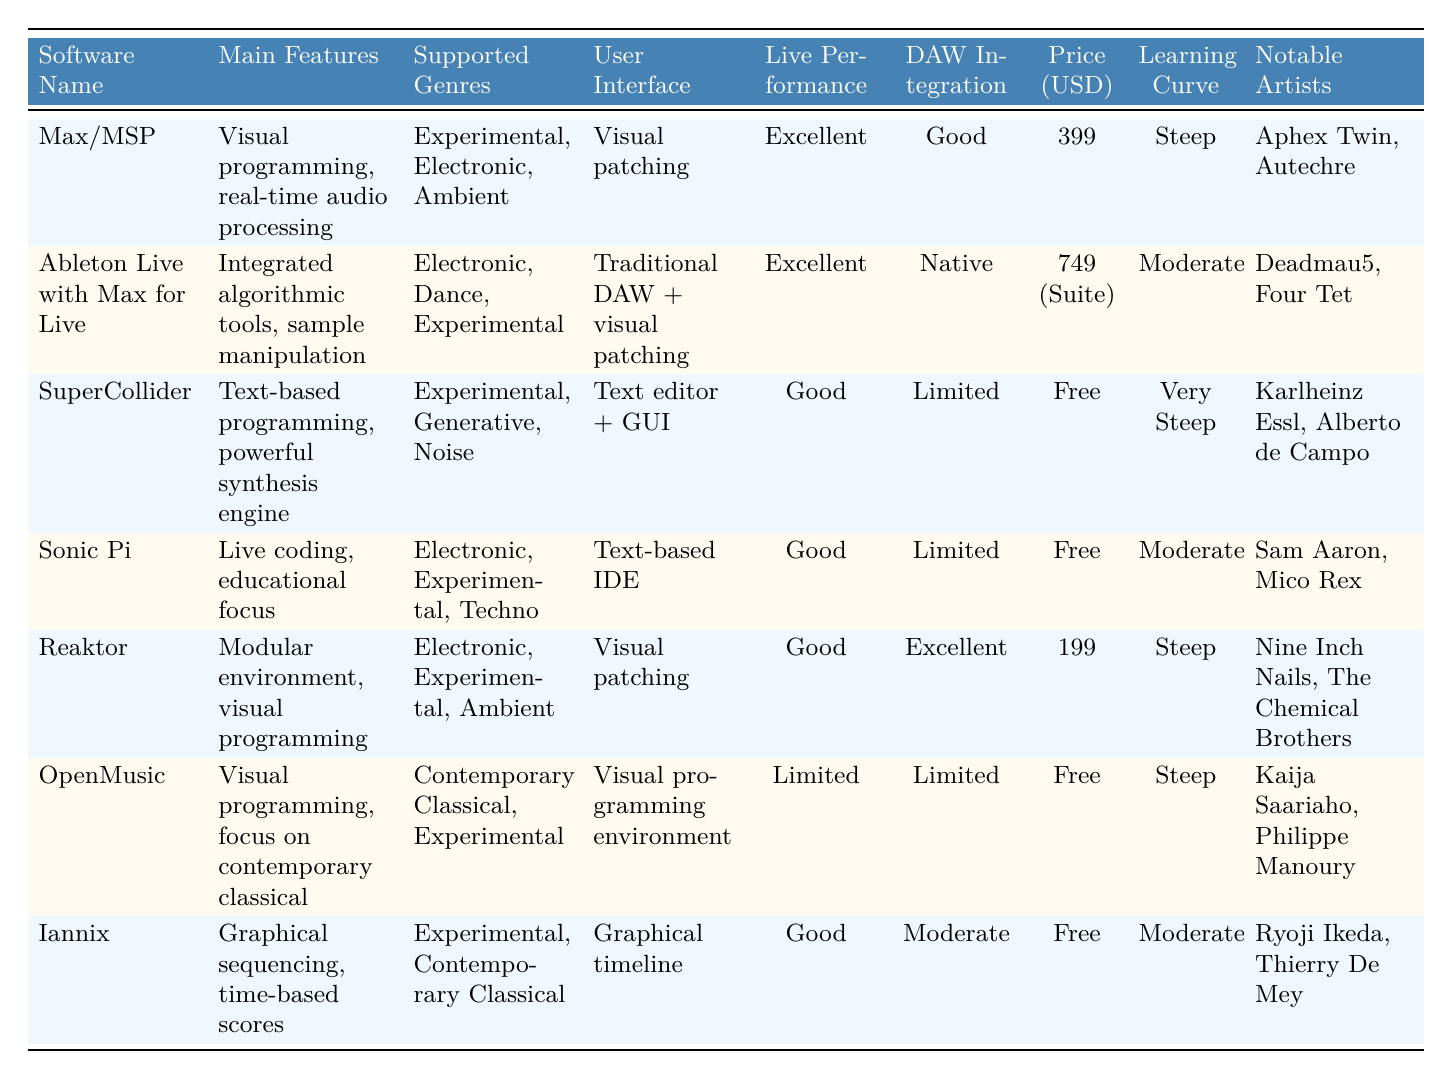What is the price of Max/MSP? The table indicates that the price for Max/MSP is listed as 399 USD.
Answer: 399 USD Which software has the highest supported genres? By reviewing the "Supported Genres" column, it appears that both Max/MSP and Ableton Live with Max for Live enjoy a wide range including Experimental, Electronic, Ambient, and Dance, whereas others are more limited. Hence they share the maximum count.
Answer: Max/MSP and Ableton Live with Max for Live Is Sonic Pi good for live performance? The table states that Sonic Pi has "Good" under the "Live Performance Capability" column, indicating that its capability for live performance is decent but not as excellent as some others.
Answer: Yes What is the learning curve for OpenMusic? According to the table, OpenMusic has a "Steep" learning curve, indicating that it may take significant time and effort to learn how to use it effectively.
Answer: Steep Which software is free and supports the genre of Experimental music? The table lists both SuperCollider and Sonic Pi as free, and both support the genre of Experimental music. Therefore, both of these software options fulfill the criteria.
Answer: SuperCollider and Sonic Pi What is the average price of the software that supports Electronic genres? The software supporting Electronic genres includes Max/MSP (399), Ableton Live with Max for Live (749), Reaktor (199), and Sonic Pi (Free, but we consider it as zero for averaging). Adding these price points gives: 399 + 749 + 199 + 0 = 1347. With the count being 3 paying software (Max/MSP, Ableton Live, Reaktor), the average is 1347 / 3 = 449.
Answer: 449 USD Does Iannix have a steep learning curve? The table shows that Iannix has a "Moderate" learning curve, which means it is not considered steep, thus indicating a relatively easier learning process.
Answer: No Which software is described as having a modular environment? From the "Main Features" column, it is evident that Reaktor is described as having a "Modular environment," distinguishing it from the others in this aspect.
Answer: Reaktor 